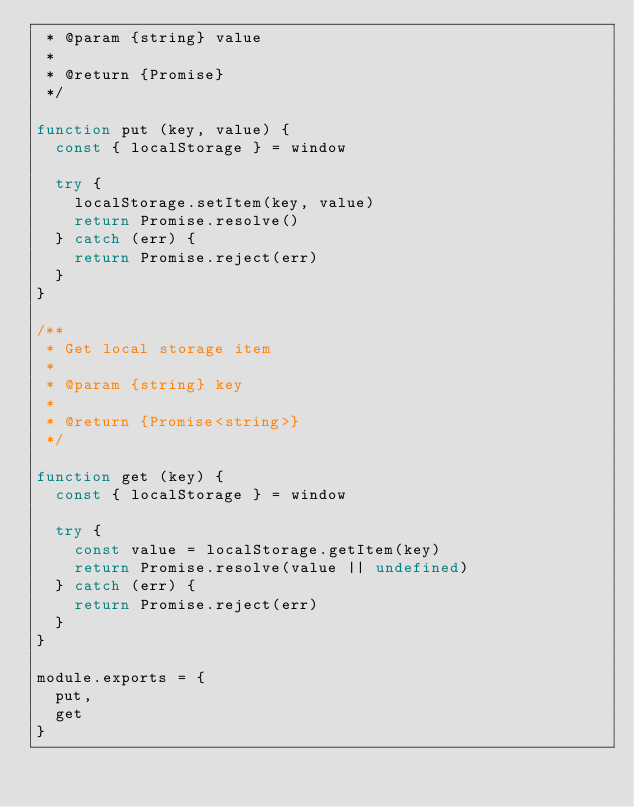Convert code to text. <code><loc_0><loc_0><loc_500><loc_500><_JavaScript_> * @param {string} value
 *
 * @return {Promise}
 */

function put (key, value) {
  const { localStorage } = window

  try {
    localStorage.setItem(key, value)
    return Promise.resolve()
  } catch (err) {
    return Promise.reject(err)
  }
}

/**
 * Get local storage item
 *
 * @param {string} key
 *
 * @return {Promise<string>}
 */

function get (key) {
  const { localStorage } = window

  try {
    const value = localStorage.getItem(key)
    return Promise.resolve(value || undefined)
  } catch (err) {
    return Promise.reject(err)
  }
}

module.exports = {
  put,
  get
}
</code> 